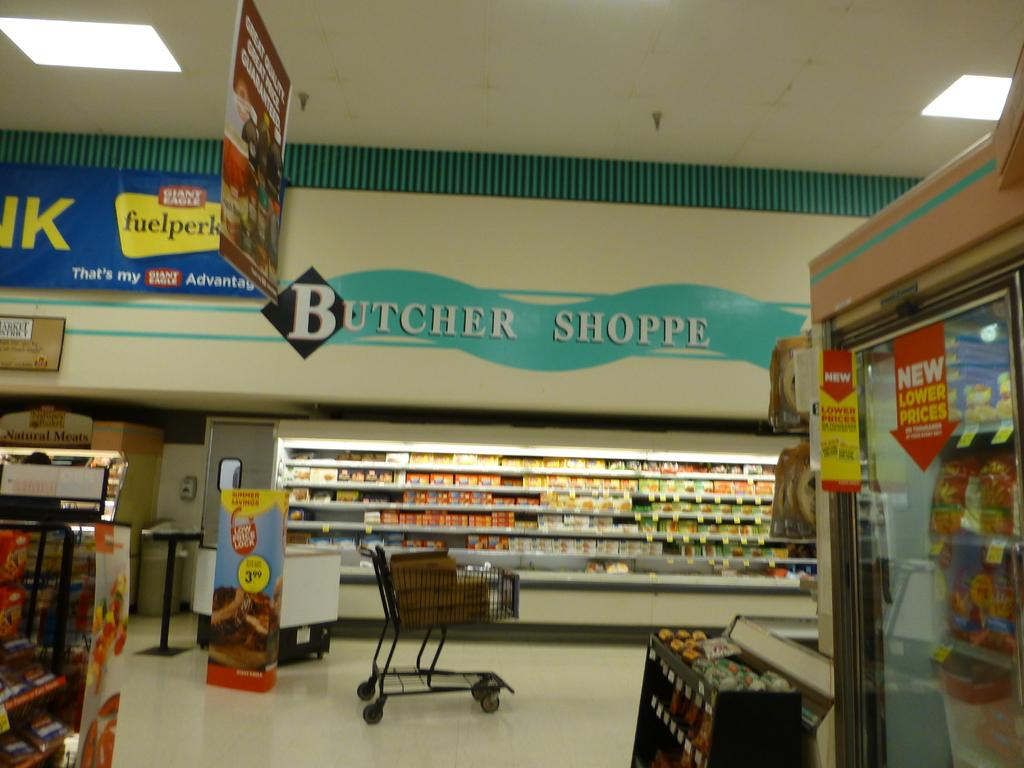Provide a one-sentence caption for the provided image. Many varities of cold cuts populate the Butcher Shoppe section of a market. 